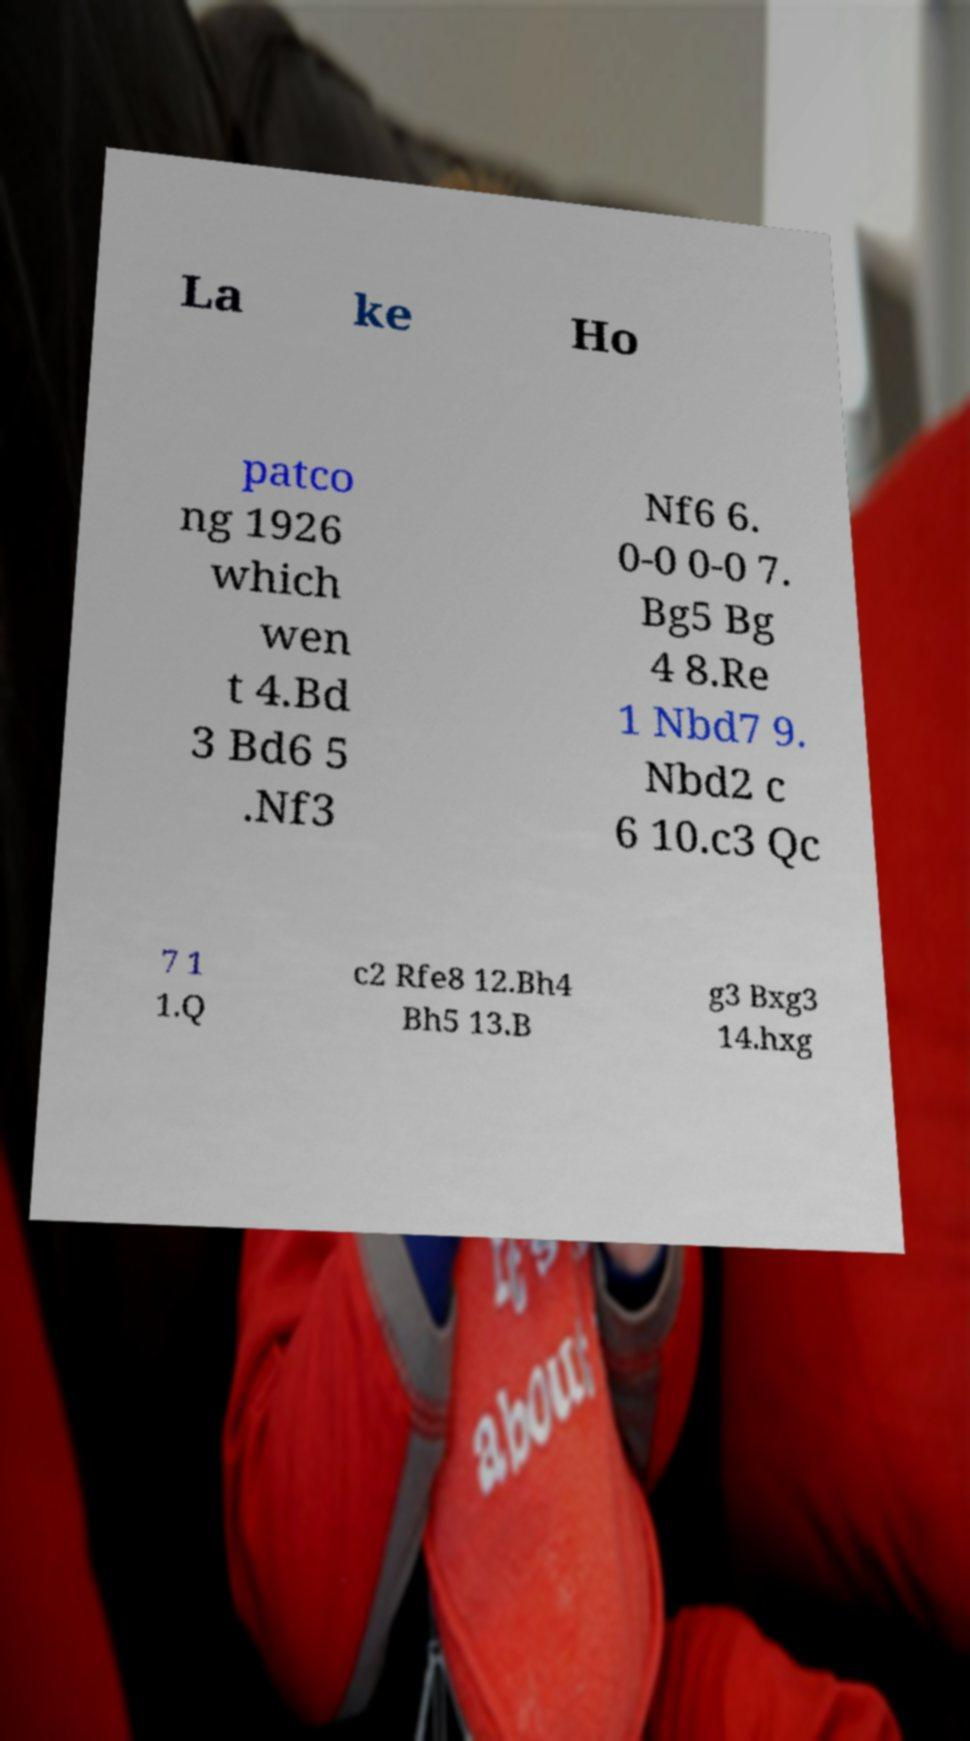For documentation purposes, I need the text within this image transcribed. Could you provide that? La ke Ho patco ng 1926 which wen t 4.Bd 3 Bd6 5 .Nf3 Nf6 6. 0-0 0-0 7. Bg5 Bg 4 8.Re 1 Nbd7 9. Nbd2 c 6 10.c3 Qc 7 1 1.Q c2 Rfe8 12.Bh4 Bh5 13.B g3 Bxg3 14.hxg 